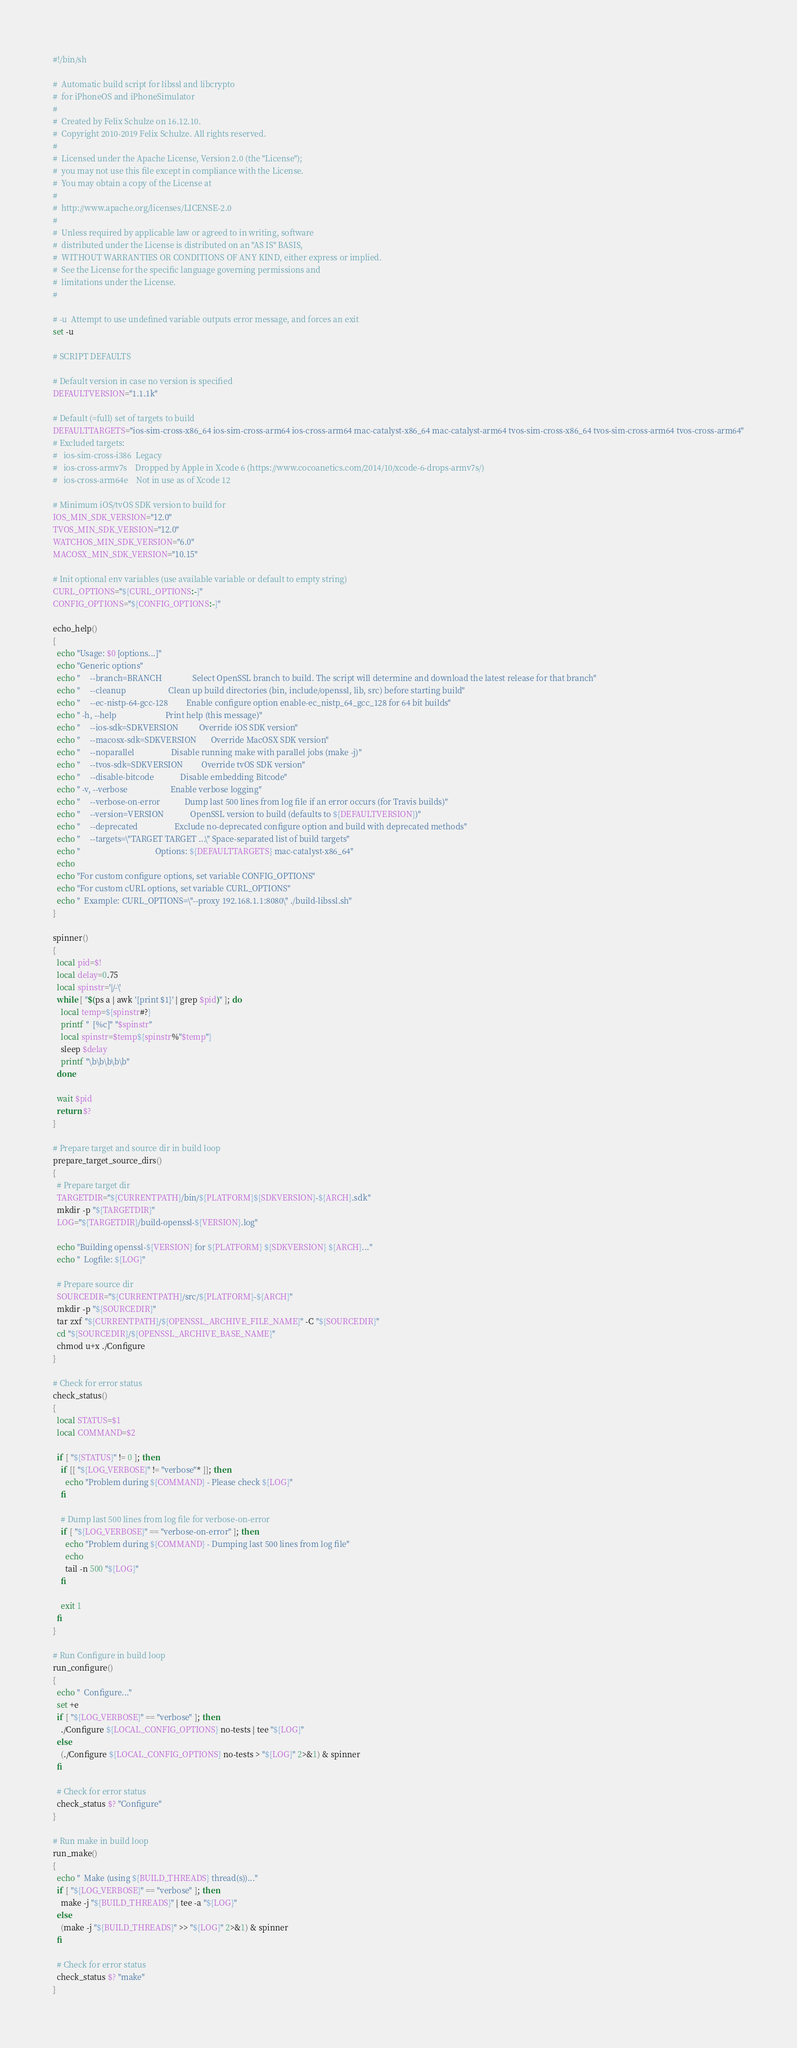Convert code to text. <code><loc_0><loc_0><loc_500><loc_500><_Bash_>#!/bin/sh

#  Automatic build script for libssl and libcrypto
#  for iPhoneOS and iPhoneSimulator
#
#  Created by Felix Schulze on 16.12.10.
#  Copyright 2010-2019 Felix Schulze. All rights reserved.
#
#  Licensed under the Apache License, Version 2.0 (the "License");
#  you may not use this file except in compliance with the License.
#  You may obtain a copy of the License at
#
#  http://www.apache.org/licenses/LICENSE-2.0
#
#  Unless required by applicable law or agreed to in writing, software
#  distributed under the License is distributed on an "AS IS" BASIS,
#  WITHOUT WARRANTIES OR CONDITIONS OF ANY KIND, either express or implied.
#  See the License for the specific language governing permissions and
#  limitations under the License.
#

# -u  Attempt to use undefined variable outputs error message, and forces an exit
set -u

# SCRIPT DEFAULTS

# Default version in case no version is specified
DEFAULTVERSION="1.1.1k"

# Default (=full) set of targets to build
DEFAULTTARGETS="ios-sim-cross-x86_64 ios-sim-cross-arm64 ios-cross-arm64 mac-catalyst-x86_64 mac-catalyst-arm64 tvos-sim-cross-x86_64 tvos-sim-cross-arm64 tvos-cross-arm64"
# Excluded targets:
#   ios-sim-cross-i386  Legacy
#   ios-cross-armv7s    Dropped by Apple in Xcode 6 (https://www.cocoanetics.com/2014/10/xcode-6-drops-armv7s/)
#   ios-cross-arm64e    Not in use as of Xcode 12

# Minimum iOS/tvOS SDK version to build for
IOS_MIN_SDK_VERSION="12.0"
TVOS_MIN_SDK_VERSION="12.0"
WATCHOS_MIN_SDK_VERSION="6.0"
MACOSX_MIN_SDK_VERSION="10.15"

# Init optional env variables (use available variable or default to empty string)
CURL_OPTIONS="${CURL_OPTIONS:-}"
CONFIG_OPTIONS="${CONFIG_OPTIONS:-}"

echo_help()
{
  echo "Usage: $0 [options...]"
  echo "Generic options"
  echo "     --branch=BRANCH               Select OpenSSL branch to build. The script will determine and download the latest release for that branch"
  echo "     --cleanup                     Clean up build directories (bin, include/openssl, lib, src) before starting build"
  echo "     --ec-nistp-64-gcc-128         Enable configure option enable-ec_nistp_64_gcc_128 for 64 bit builds"
  echo " -h, --help                        Print help (this message)"
  echo "     --ios-sdk=SDKVERSION          Override iOS SDK version"
  echo "     --macosx-sdk=SDKVERSION       Override MacOSX SDK version"
  echo "     --noparallel                  Disable running make with parallel jobs (make -j)"
  echo "     --tvos-sdk=SDKVERSION         Override tvOS SDK version"
  echo "     --disable-bitcode             Disable embedding Bitcode"
  echo " -v, --verbose                     Enable verbose logging"
  echo "     --verbose-on-error            Dump last 500 lines from log file if an error occurs (for Travis builds)"
  echo "     --version=VERSION             OpenSSL version to build (defaults to ${DEFAULTVERSION})"
  echo "     --deprecated                  Exclude no-deprecated configure option and build with deprecated methods"
  echo "     --targets=\"TARGET TARGET ...\" Space-separated list of build targets"
  echo "                                     Options: ${DEFAULTTARGETS} mac-catalyst-x86_64"
  echo
  echo "For custom configure options, set variable CONFIG_OPTIONS"
  echo "For custom cURL options, set variable CURL_OPTIONS"
  echo "  Example: CURL_OPTIONS=\"--proxy 192.168.1.1:8080\" ./build-libssl.sh"
}

spinner()
{
  local pid=$!
  local delay=0.75
  local spinstr='|/-\'
  while [ "$(ps a | awk '{print $1}' | grep $pid)" ]; do
    local temp=${spinstr#?}
    printf "  [%c]" "$spinstr"
    local spinstr=$temp${spinstr%"$temp"}
    sleep $delay
    printf "\b\b\b\b\b"
  done

  wait $pid
  return $?
}

# Prepare target and source dir in build loop
prepare_target_source_dirs()
{
  # Prepare target dir
  TARGETDIR="${CURRENTPATH}/bin/${PLATFORM}${SDKVERSION}-${ARCH}.sdk"
  mkdir -p "${TARGETDIR}"
  LOG="${TARGETDIR}/build-openssl-${VERSION}.log"

  echo "Building openssl-${VERSION} for ${PLATFORM} ${SDKVERSION} ${ARCH}..."
  echo "  Logfile: ${LOG}"

  # Prepare source dir
  SOURCEDIR="${CURRENTPATH}/src/${PLATFORM}-${ARCH}"
  mkdir -p "${SOURCEDIR}"
  tar zxf "${CURRENTPATH}/${OPENSSL_ARCHIVE_FILE_NAME}" -C "${SOURCEDIR}"
  cd "${SOURCEDIR}/${OPENSSL_ARCHIVE_BASE_NAME}"
  chmod u+x ./Configure
}

# Check for error status
check_status()
{
  local STATUS=$1
  local COMMAND=$2

  if [ "${STATUS}" != 0 ]; then
    if [[ "${LOG_VERBOSE}" != "verbose"* ]]; then
      echo "Problem during ${COMMAND} - Please check ${LOG}"
    fi

    # Dump last 500 lines from log file for verbose-on-error
    if [ "${LOG_VERBOSE}" == "verbose-on-error" ]; then
      echo "Problem during ${COMMAND} - Dumping last 500 lines from log file"
      echo
      tail -n 500 "${LOG}"
    fi

    exit 1
  fi
}

# Run Configure in build loop
run_configure()
{
  echo "  Configure..."
  set +e
  if [ "${LOG_VERBOSE}" == "verbose" ]; then
    ./Configure ${LOCAL_CONFIG_OPTIONS} no-tests | tee "${LOG}"
  else
    (./Configure ${LOCAL_CONFIG_OPTIONS} no-tests > "${LOG}" 2>&1) & spinner
  fi

  # Check for error status
  check_status $? "Configure"
}

# Run make in build loop
run_make()
{
  echo "  Make (using ${BUILD_THREADS} thread(s))..."
  if [ "${LOG_VERBOSE}" == "verbose" ]; then
    make -j "${BUILD_THREADS}" | tee -a "${LOG}"
  else
    (make -j "${BUILD_THREADS}" >> "${LOG}" 2>&1) & spinner
  fi

  # Check for error status
  check_status $? "make"
}
</code> 